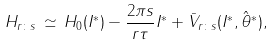<formula> <loc_0><loc_0><loc_500><loc_500>H _ { r \colon s } \, \simeq \, H _ { 0 } ( I ^ { * } ) - \frac { 2 \pi s } { r \tau } I ^ { * } + \bar { V } _ { r \colon s } ( I ^ { * } , \hat { \theta } ^ { * } ) ,</formula> 